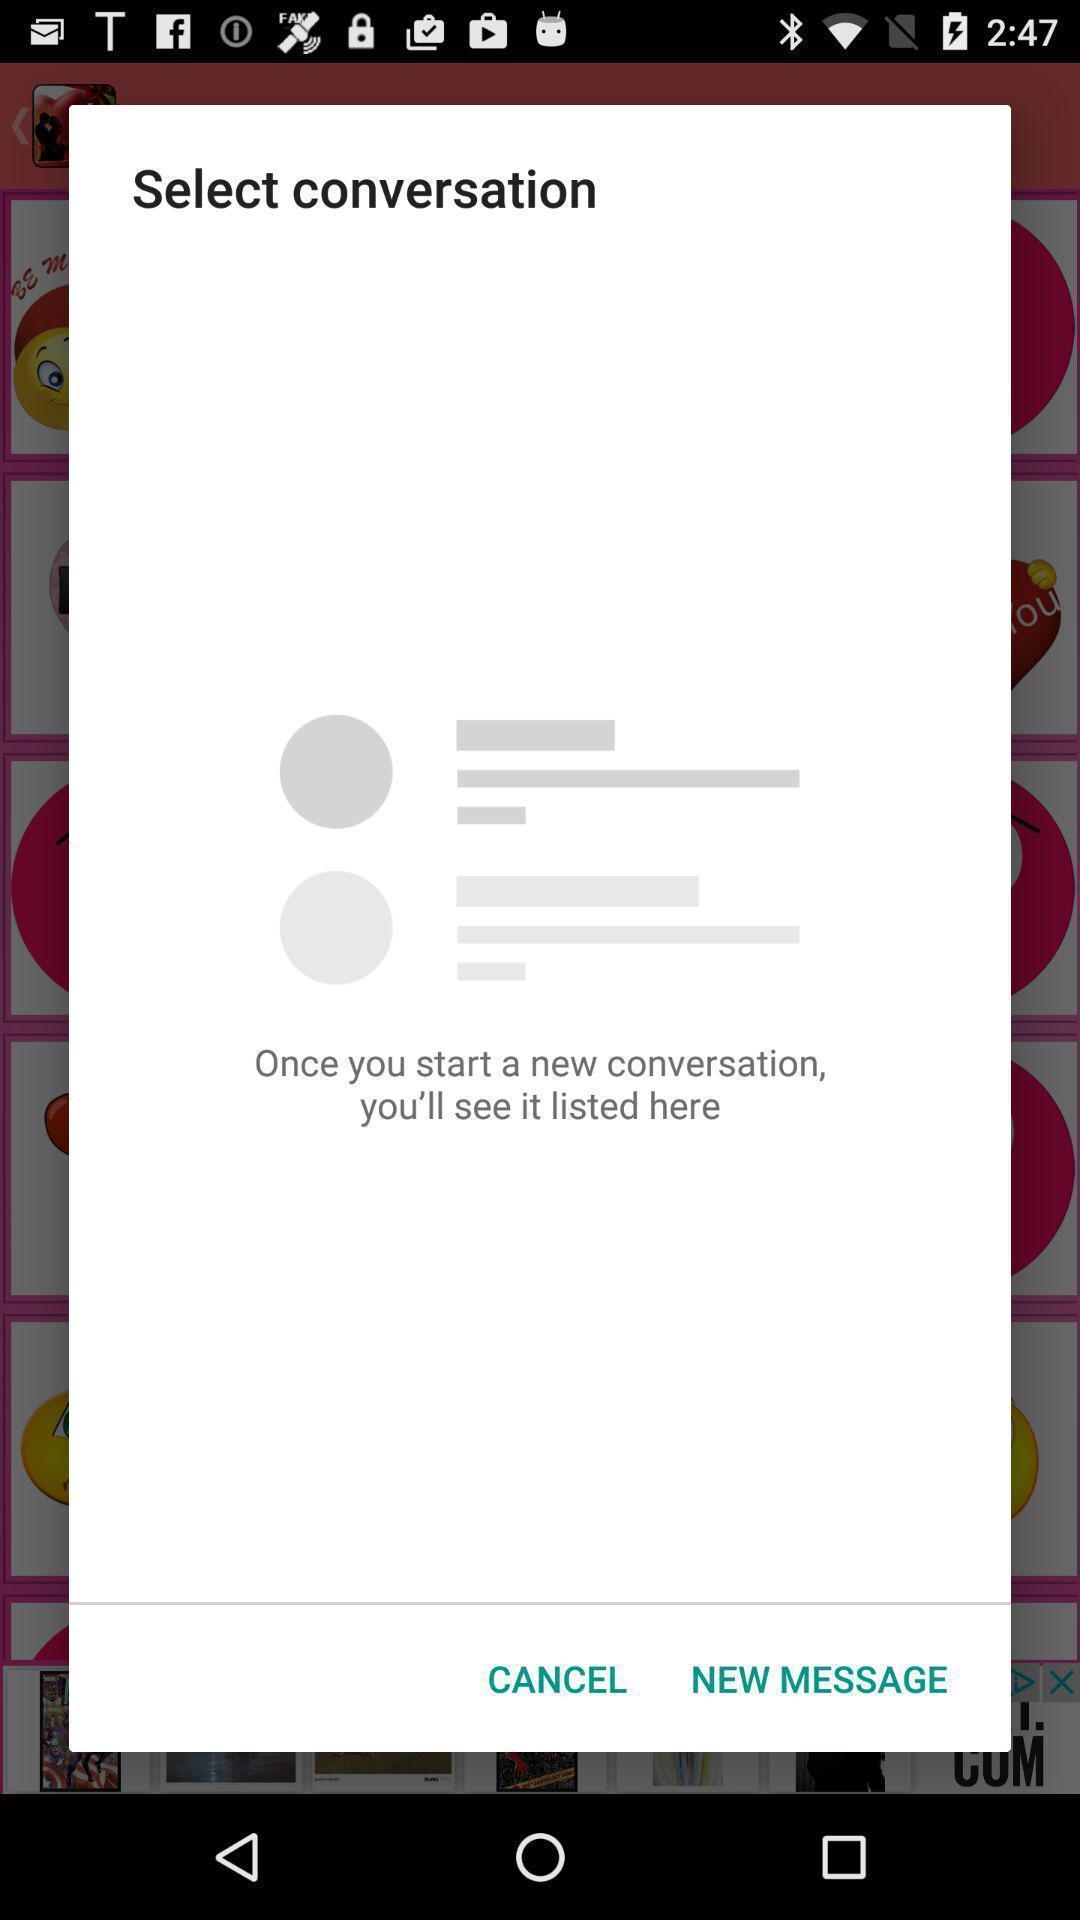What details can you identify in this image? Pop-up showing option like new message. 